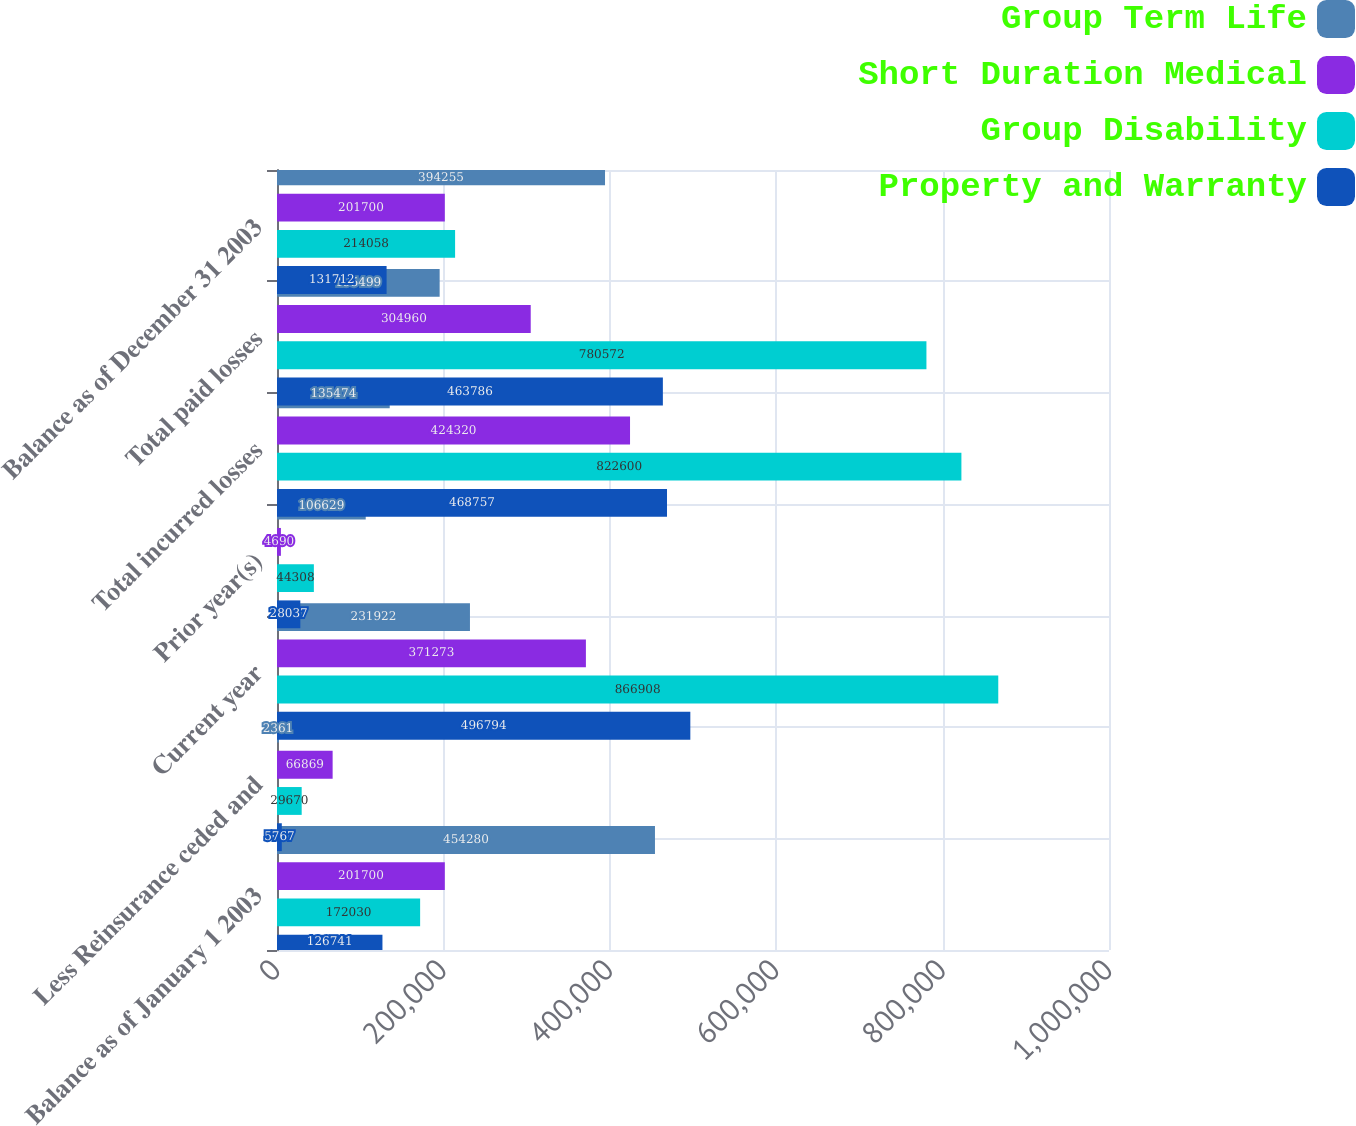Convert chart. <chart><loc_0><loc_0><loc_500><loc_500><stacked_bar_chart><ecel><fcel>Balance as of January 1 2003<fcel>Less Reinsurance ceded and<fcel>Current year<fcel>Prior year(s)<fcel>Total incurred losses<fcel>Total paid losses<fcel>Balance as of December 31 2003<nl><fcel>Group Term Life<fcel>454280<fcel>2361<fcel>231922<fcel>106629<fcel>135474<fcel>195499<fcel>394255<nl><fcel>Short Duration Medical<fcel>201700<fcel>66869<fcel>371273<fcel>4690<fcel>424320<fcel>304960<fcel>201700<nl><fcel>Group Disability<fcel>172030<fcel>29670<fcel>866908<fcel>44308<fcel>822600<fcel>780572<fcel>214058<nl><fcel>Property and Warranty<fcel>126741<fcel>5767<fcel>496794<fcel>28037<fcel>468757<fcel>463786<fcel>131712<nl></chart> 